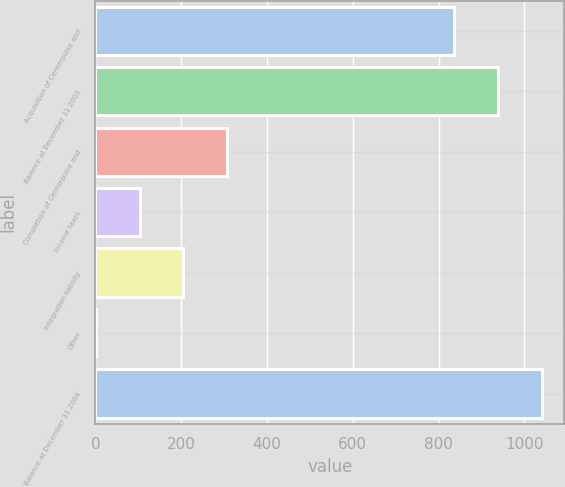Convert chart. <chart><loc_0><loc_0><loc_500><loc_500><bar_chart><fcel>Acquisition of Centerpulse and<fcel>Balance at December 31 2003<fcel>Completion of Centerpulse and<fcel>Income taxes<fcel>Integration liability<fcel>Other<fcel>Balance at December 31 2004<nl><fcel>836.3<fcel>938.54<fcel>307.52<fcel>103.04<fcel>205.28<fcel>0.8<fcel>1040.78<nl></chart> 